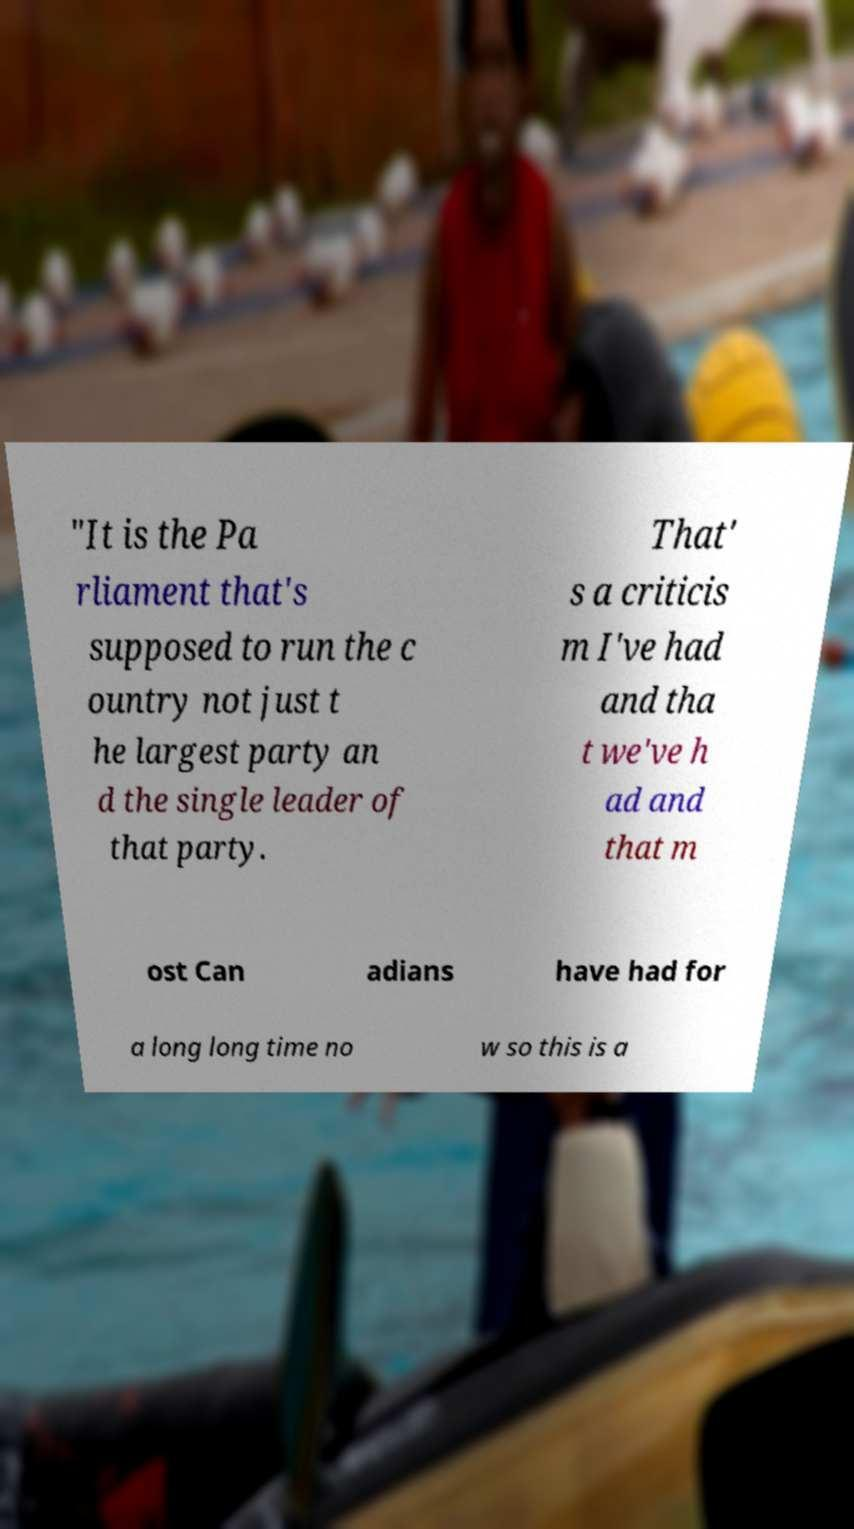I need the written content from this picture converted into text. Can you do that? "It is the Pa rliament that's supposed to run the c ountry not just t he largest party an d the single leader of that party. That' s a criticis m I've had and tha t we've h ad and that m ost Can adians have had for a long long time no w so this is a 